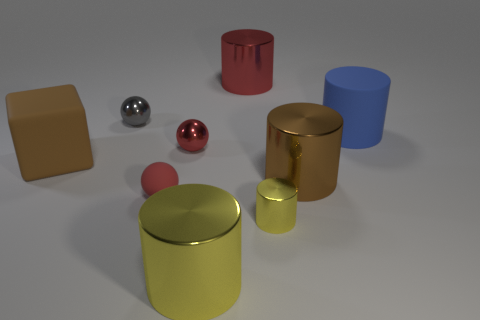Subtract all blue cylinders. How many cylinders are left? 4 Subtract all brown cylinders. How many cylinders are left? 4 Subtract all green cylinders. Subtract all red cubes. How many cylinders are left? 5 Subtract all blocks. How many objects are left? 8 Add 3 red metallic spheres. How many red metallic spheres exist? 4 Subtract 1 brown blocks. How many objects are left? 8 Subtract all blue rubber cylinders. Subtract all small shiny things. How many objects are left? 5 Add 5 small shiny objects. How many small shiny objects are left? 8 